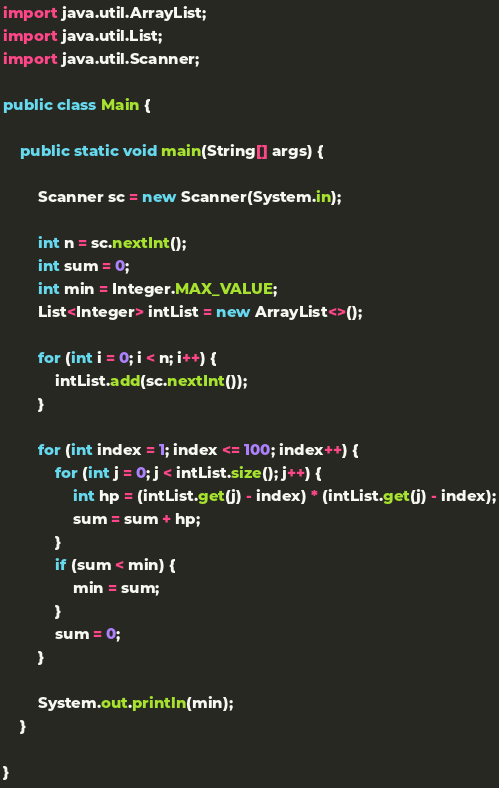Convert code to text. <code><loc_0><loc_0><loc_500><loc_500><_Java_>import java.util.ArrayList;
import java.util.List;
import java.util.Scanner;

public class Main {

	public static void main(String[] args) {

		Scanner sc = new Scanner(System.in);

		int n = sc.nextInt();
		int sum = 0;
		int min = Integer.MAX_VALUE;
		List<Integer> intList = new ArrayList<>();

		for (int i = 0; i < n; i++) {
			intList.add(sc.nextInt());
		}

		for (int index = 1; index <= 100; index++) {
			for (int j = 0; j < intList.size(); j++) {
				int hp = (intList.get(j) - index) * (intList.get(j) - index);
				sum = sum + hp;
			}
			if (sum < min) {
				min = sum;
			}
			sum = 0;
		}

		System.out.println(min);
	}

}</code> 